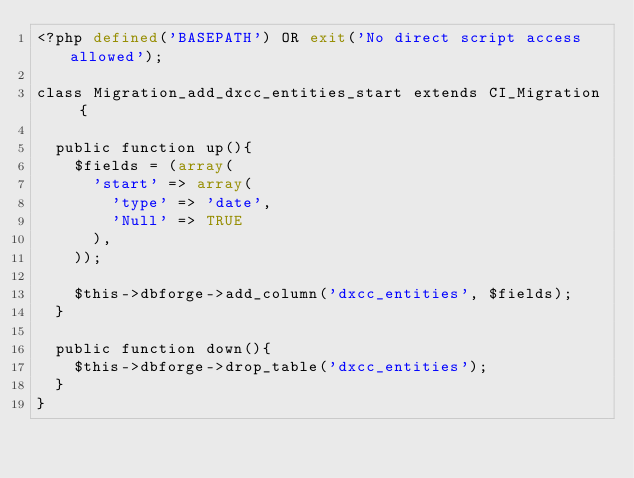Convert code to text. <code><loc_0><loc_0><loc_500><loc_500><_PHP_><?php defined('BASEPATH') OR exit('No direct script access allowed');

class Migration_add_dxcc_entities_start extends CI_Migration {

  public function up(){
    $fields = (array(
      'start' => array(
        'type' => 'date',
        'Null' => TRUE
      ),
    ));

    $this->dbforge->add_column('dxcc_entities', $fields);
  }

  public function down(){
    $this->dbforge->drop_table('dxcc_entities');
  }
}
</code> 